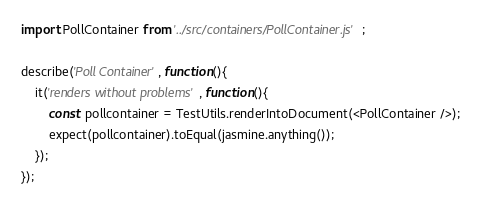<code> <loc_0><loc_0><loc_500><loc_500><_JavaScript_>import PollContainer from '../src/containers/PollContainer.js';

describe('Poll Container', function(){
    it('renders without problems', function(){
        const pollcontainer = TestUtils.renderIntoDocument(<PollContainer />);
        expect(pollcontainer).toEqual(jasmine.anything());
    });
});</code> 